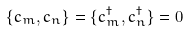<formula> <loc_0><loc_0><loc_500><loc_500>\{ c _ { m } , c _ { n } \} = \{ c _ { m } ^ { \dagger } , c _ { n } ^ { \dagger } \} = 0</formula> 